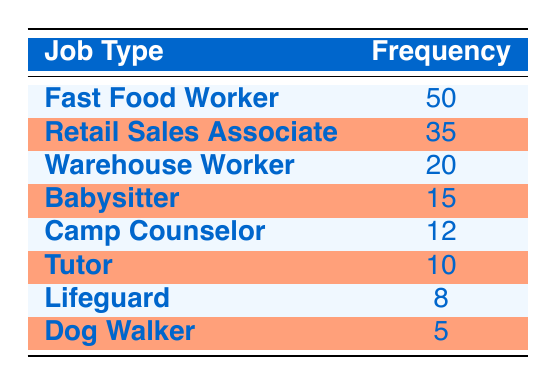What's the most common part-time job type among students aged 16-18? Looking at the frequency column, the job type with the highest frequency is "Fast Food Worker," as it has a frequency of 50, which is greater than all other job types listed.
Answer: Fast Food Worker How many students work as Retail Sales Associates? According to the table, the frequency of "Retail Sales Associate" is 35, indicating that there are 35 students working in this job.
Answer: 35 What is the total frequency of jobs in which students work? To find the total frequency, we sum the frequencies of all job types: 50 + 35 + 20 + 15 + 12 + 10 + 8 + 5 = 155. Therefore, the total number of students working part-time is 155.
Answer: 155 Which job type has a frequency between 10 and 20? By reviewing the frequency values, "Babysitter" has a frequency of 15 and "Camp Counselor" has a frequency of 12, both of which are between 10 and 20.
Answer: Babysitter, Camp Counselor Is it true that more than 40 students work as Fast Food Workers? The frequency for "Fast Food Worker" is 50, which is greater than 40; therefore, the statement is true.
Answer: Yes What is the least common part-time job type among the students? Looking through the frequency column, "Dog Walker" has the lowest frequency at 5, indicating it is the least common job type.
Answer: Dog Walker What is the average frequency of all part-time job types held by students aged 16-18? To calculate the average, first, we sum the frequencies to get 155 as previously calculated. There are 8 job types, so we divide 155 by 8, which equals approximately 19.375.
Answer: 19.375 If the frequency of Tutors increased by 5, what would their new frequency be? The current frequency of "Tutor" is 10. If we add 5 to this amount (10 + 5), the new frequency would be 15.
Answer: 15 Which job type has a higher frequency, Lifeguard or Warehouse Worker? Comparing the frequencies, "Warehouse Worker" has a frequency of 20, whereas "Lifeguard" has a frequency of 8. Since 20 is greater than 8, "Warehouse Worker" has a higher frequency.
Answer: Warehouse Worker 